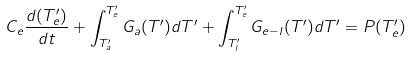<formula> <loc_0><loc_0><loc_500><loc_500>C _ { e } \frac { d ( T ^ { \prime } _ { e } ) } { d t } + \int _ { T ^ { \prime } _ { a } } ^ { T ^ { \prime } _ { e } } G _ { a } ( T ^ { \prime } ) d T ^ { \prime } + \int _ { T ^ { \prime } _ { l } } ^ { T ^ { \prime } _ { e } } G _ { e - l } ( T ^ { \prime } ) d T ^ { \prime } = P ( T ^ { \prime } _ { e } )</formula> 